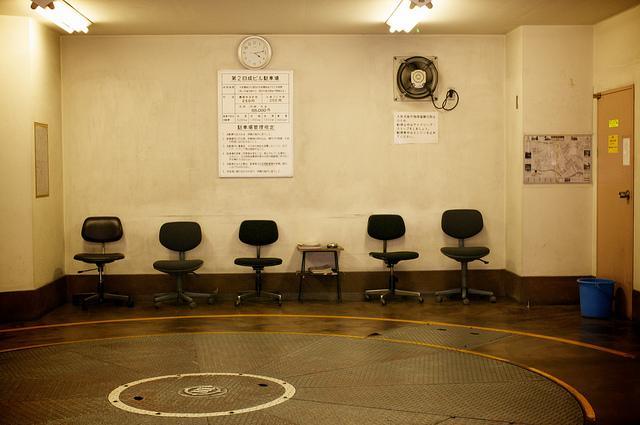What concentric shapes are on the ground?
Keep it brief. Circles. Are the chairs leather?
Short answer required. No. How many chairs are there?
Keep it brief. 5. 